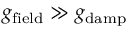<formula> <loc_0><loc_0><loc_500><loc_500>g _ { f i e l d } \gg g _ { d a m p }</formula> 